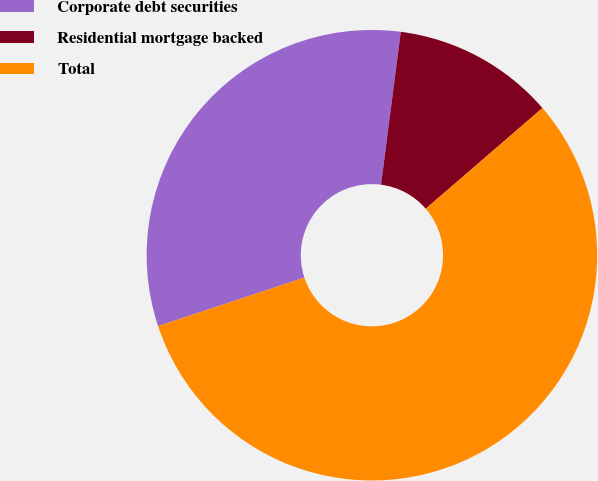<chart> <loc_0><loc_0><loc_500><loc_500><pie_chart><fcel>Corporate debt securities<fcel>Residential mortgage backed<fcel>Total<nl><fcel>32.14%<fcel>11.62%<fcel>56.23%<nl></chart> 